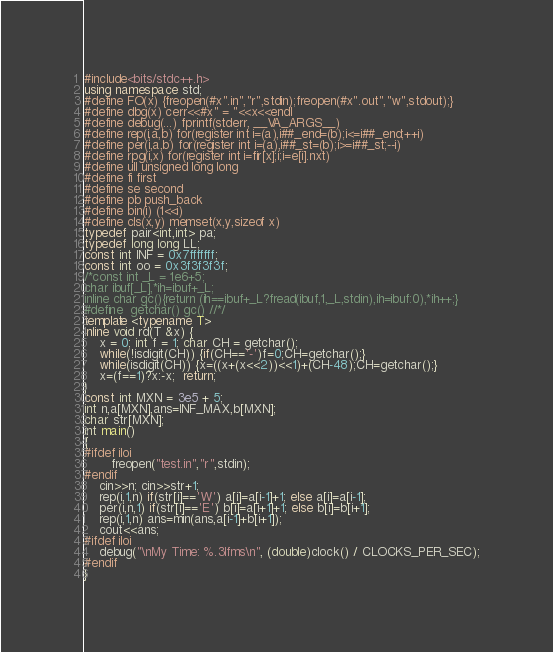Convert code to text. <code><loc_0><loc_0><loc_500><loc_500><_C++_>#include<bits/stdc++.h>
using namespace std;
#define FO(x) {freopen(#x".in","r",stdin);freopen(#x".out","w",stdout);}
#define dbg(x) cerr<<#x" = "<<x<<endl
#define debug(...) fprintf(stderr, __VA_ARGS__)
#define rep(i,a,b) for(register int i=(a),i##_end=(b);i<=i##_end;++i)
#define per(i,a,b) for(register int i=(a),i##_st=(b);i>=i##_st;--i)
#define rpg(i,x) for(register int i=fir[x];i;i=e[i].nxt)
#define ull unsigned long long
#define fi first
#define se second
#define pb push_back
#define bin(i) (1<<i)
#define cls(x,y) memset(x,y,sizeof x)
typedef pair<int,int> pa;
typedef long long LL;
const int INF = 0x7fffffff;
const int oo = 0x3f3f3f3f;
/*const int _L = 1e6+5;
char ibuf[_L],*ih=ibuf+_L;
inline char gc(){return (ih==ibuf+_L?fread(ibuf,1,_L,stdin),ih=ibuf:0),*ih++;}
#define  getchar() gc() //*/
template <typename T>
inline void rd(T &x) {
    x = 0; int f = 1; char CH = getchar();
    while(!isdigit(CH)) {if(CH=='-')f=0;CH=getchar();}
    while(isdigit(CH)) {x=((x+(x<<2))<<1)+(CH-48);CH=getchar();}
    x=(f==1)?x:-x;  return;
}
const int MXN = 3e5 + 5;
int n,a[MXN],ans=INF_MAX,b[MXN];
char str[MXN];
int main()
{
#ifdef iloi
	   freopen("test.in","r",stdin);
#endif
	cin>>n; cin>>str+1;
	rep(i,1,n) if(str[i]=='W') a[i]=a[i-1]+1; else a[i]=a[i-1];
	per(i,n,1) if(str[i]=='E') b[i]=a[i+1]+1; else b[i]=b[i+1];
	rep(i,1,n) ans=min(ans,a[i-1]+b[i+1]);
	cout<<ans;
#ifdef iloi
	debug("\nMy Time: %.3lfms\n", (double)clock() / CLOCKS_PER_SEC);
#endif
}
</code> 